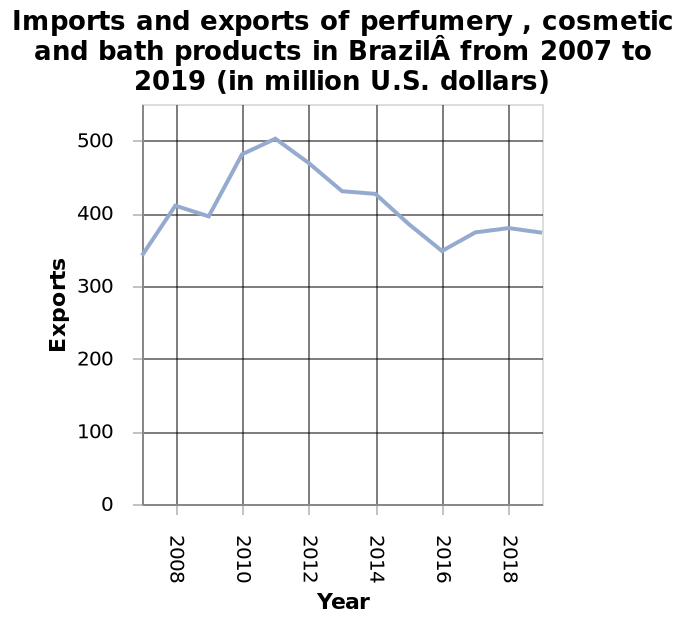<image>
What is the variable plotted on the y-axis of the line plot? The variable plotted on the y-axis of the line plot is Exports. What is the unit of measurement for the values on the y-axis? The unit of measurement for the values on the y-axis is million U.S. dollars. please describe the details of the chart Imports and exports of perfumery , cosmetic and bath products in BrazilÂ from 2007 to 2019 (in million U.S. dollars) is a line plot. A linear scale from 2008 to 2018 can be found on the x-axis, labeled Year. Exports is drawn on the y-axis. 